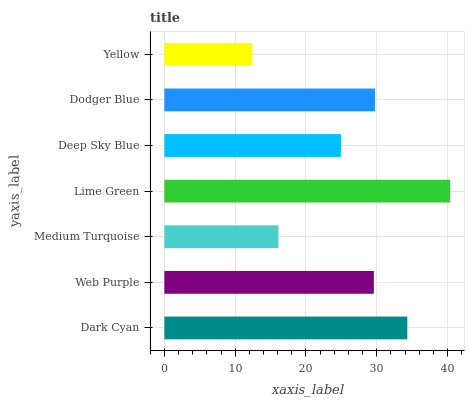Is Yellow the minimum?
Answer yes or no. Yes. Is Lime Green the maximum?
Answer yes or no. Yes. Is Web Purple the minimum?
Answer yes or no. No. Is Web Purple the maximum?
Answer yes or no. No. Is Dark Cyan greater than Web Purple?
Answer yes or no. Yes. Is Web Purple less than Dark Cyan?
Answer yes or no. Yes. Is Web Purple greater than Dark Cyan?
Answer yes or no. No. Is Dark Cyan less than Web Purple?
Answer yes or no. No. Is Web Purple the high median?
Answer yes or no. Yes. Is Web Purple the low median?
Answer yes or no. Yes. Is Dark Cyan the high median?
Answer yes or no. No. Is Dark Cyan the low median?
Answer yes or no. No. 